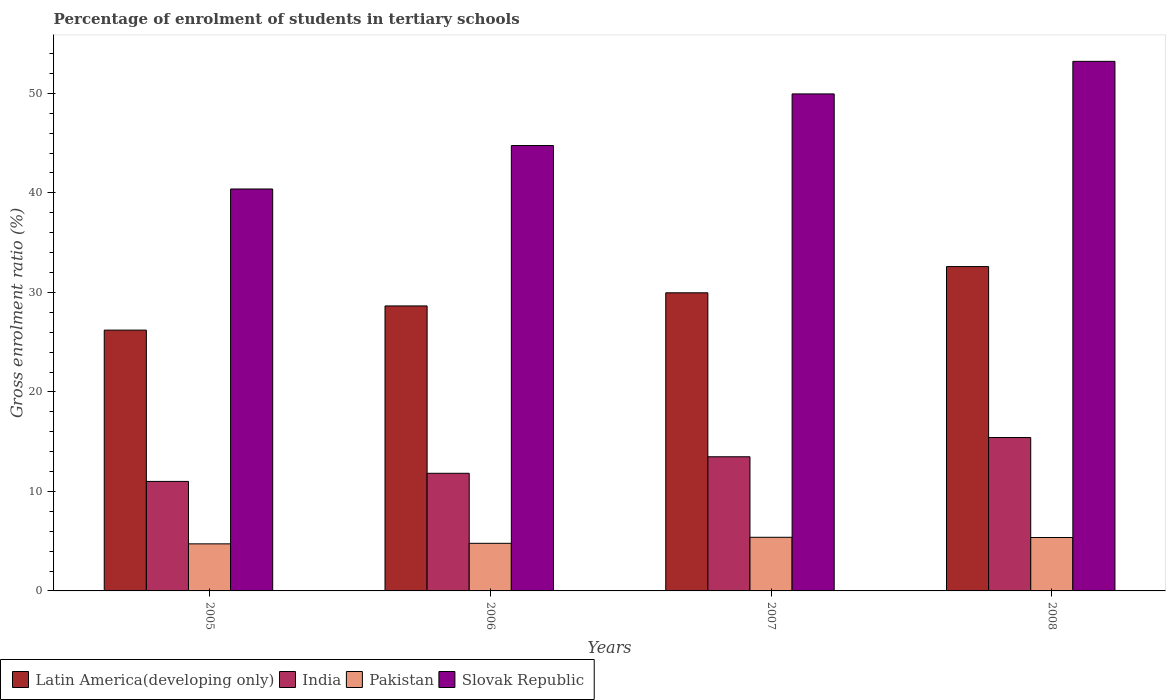How many different coloured bars are there?
Provide a short and direct response. 4. How many bars are there on the 1st tick from the left?
Offer a very short reply. 4. What is the label of the 2nd group of bars from the left?
Provide a short and direct response. 2006. What is the percentage of students enrolled in tertiary schools in Slovak Republic in 2006?
Make the answer very short. 44.76. Across all years, what is the maximum percentage of students enrolled in tertiary schools in Slovak Republic?
Ensure brevity in your answer.  53.22. Across all years, what is the minimum percentage of students enrolled in tertiary schools in Slovak Republic?
Provide a short and direct response. 40.39. In which year was the percentage of students enrolled in tertiary schools in India maximum?
Give a very brief answer. 2008. What is the total percentage of students enrolled in tertiary schools in Latin America(developing only) in the graph?
Offer a very short reply. 117.4. What is the difference between the percentage of students enrolled in tertiary schools in Latin America(developing only) in 2006 and that in 2008?
Ensure brevity in your answer.  -3.95. What is the difference between the percentage of students enrolled in tertiary schools in India in 2005 and the percentage of students enrolled in tertiary schools in Slovak Republic in 2006?
Offer a terse response. -33.75. What is the average percentage of students enrolled in tertiary schools in Slovak Republic per year?
Your response must be concise. 47.08. In the year 2007, what is the difference between the percentage of students enrolled in tertiary schools in India and percentage of students enrolled in tertiary schools in Slovak Republic?
Ensure brevity in your answer.  -36.46. What is the ratio of the percentage of students enrolled in tertiary schools in Latin America(developing only) in 2005 to that in 2008?
Your answer should be compact. 0.8. Is the percentage of students enrolled in tertiary schools in Latin America(developing only) in 2005 less than that in 2006?
Your answer should be very brief. Yes. Is the difference between the percentage of students enrolled in tertiary schools in India in 2006 and 2007 greater than the difference between the percentage of students enrolled in tertiary schools in Slovak Republic in 2006 and 2007?
Offer a terse response. Yes. What is the difference between the highest and the second highest percentage of students enrolled in tertiary schools in India?
Offer a terse response. 1.93. What is the difference between the highest and the lowest percentage of students enrolled in tertiary schools in India?
Keep it short and to the point. 4.41. In how many years, is the percentage of students enrolled in tertiary schools in Slovak Republic greater than the average percentage of students enrolled in tertiary schools in Slovak Republic taken over all years?
Your response must be concise. 2. Is it the case that in every year, the sum of the percentage of students enrolled in tertiary schools in Pakistan and percentage of students enrolled in tertiary schools in Slovak Republic is greater than the sum of percentage of students enrolled in tertiary schools in India and percentage of students enrolled in tertiary schools in Latin America(developing only)?
Offer a very short reply. No. What does the 4th bar from the right in 2008 represents?
Your answer should be very brief. Latin America(developing only). Are all the bars in the graph horizontal?
Provide a short and direct response. No. How many years are there in the graph?
Give a very brief answer. 4. What is the difference between two consecutive major ticks on the Y-axis?
Your answer should be very brief. 10. Are the values on the major ticks of Y-axis written in scientific E-notation?
Offer a terse response. No. Does the graph contain grids?
Make the answer very short. No. How many legend labels are there?
Your response must be concise. 4. How are the legend labels stacked?
Offer a very short reply. Horizontal. What is the title of the graph?
Provide a short and direct response. Percentage of enrolment of students in tertiary schools. What is the label or title of the Y-axis?
Provide a succinct answer. Gross enrolment ratio (%). What is the Gross enrolment ratio (%) in Latin America(developing only) in 2005?
Make the answer very short. 26.21. What is the Gross enrolment ratio (%) of India in 2005?
Provide a short and direct response. 11. What is the Gross enrolment ratio (%) of Pakistan in 2005?
Give a very brief answer. 4.73. What is the Gross enrolment ratio (%) of Slovak Republic in 2005?
Provide a short and direct response. 40.39. What is the Gross enrolment ratio (%) in Latin America(developing only) in 2006?
Keep it short and to the point. 28.64. What is the Gross enrolment ratio (%) in India in 2006?
Provide a succinct answer. 11.82. What is the Gross enrolment ratio (%) in Pakistan in 2006?
Provide a short and direct response. 4.78. What is the Gross enrolment ratio (%) of Slovak Republic in 2006?
Offer a terse response. 44.76. What is the Gross enrolment ratio (%) of Latin America(developing only) in 2007?
Your answer should be very brief. 29.96. What is the Gross enrolment ratio (%) of India in 2007?
Keep it short and to the point. 13.48. What is the Gross enrolment ratio (%) in Pakistan in 2007?
Give a very brief answer. 5.39. What is the Gross enrolment ratio (%) of Slovak Republic in 2007?
Keep it short and to the point. 49.95. What is the Gross enrolment ratio (%) of Latin America(developing only) in 2008?
Keep it short and to the point. 32.59. What is the Gross enrolment ratio (%) of India in 2008?
Make the answer very short. 15.42. What is the Gross enrolment ratio (%) of Pakistan in 2008?
Offer a terse response. 5.37. What is the Gross enrolment ratio (%) in Slovak Republic in 2008?
Provide a short and direct response. 53.22. Across all years, what is the maximum Gross enrolment ratio (%) of Latin America(developing only)?
Provide a succinct answer. 32.59. Across all years, what is the maximum Gross enrolment ratio (%) of India?
Your response must be concise. 15.42. Across all years, what is the maximum Gross enrolment ratio (%) in Pakistan?
Provide a succinct answer. 5.39. Across all years, what is the maximum Gross enrolment ratio (%) of Slovak Republic?
Offer a very short reply. 53.22. Across all years, what is the minimum Gross enrolment ratio (%) in Latin America(developing only)?
Provide a succinct answer. 26.21. Across all years, what is the minimum Gross enrolment ratio (%) in India?
Your answer should be compact. 11. Across all years, what is the minimum Gross enrolment ratio (%) of Pakistan?
Make the answer very short. 4.73. Across all years, what is the minimum Gross enrolment ratio (%) of Slovak Republic?
Your response must be concise. 40.39. What is the total Gross enrolment ratio (%) in Latin America(developing only) in the graph?
Provide a short and direct response. 117.4. What is the total Gross enrolment ratio (%) of India in the graph?
Offer a very short reply. 51.72. What is the total Gross enrolment ratio (%) in Pakistan in the graph?
Your answer should be compact. 20.27. What is the total Gross enrolment ratio (%) of Slovak Republic in the graph?
Offer a terse response. 188.31. What is the difference between the Gross enrolment ratio (%) of Latin America(developing only) in 2005 and that in 2006?
Your answer should be compact. -2.43. What is the difference between the Gross enrolment ratio (%) in India in 2005 and that in 2006?
Your response must be concise. -0.82. What is the difference between the Gross enrolment ratio (%) in Pakistan in 2005 and that in 2006?
Keep it short and to the point. -0.05. What is the difference between the Gross enrolment ratio (%) of Slovak Republic in 2005 and that in 2006?
Make the answer very short. -4.37. What is the difference between the Gross enrolment ratio (%) in Latin America(developing only) in 2005 and that in 2007?
Provide a succinct answer. -3.75. What is the difference between the Gross enrolment ratio (%) of India in 2005 and that in 2007?
Your answer should be very brief. -2.48. What is the difference between the Gross enrolment ratio (%) in Pakistan in 2005 and that in 2007?
Your answer should be very brief. -0.66. What is the difference between the Gross enrolment ratio (%) in Slovak Republic in 2005 and that in 2007?
Provide a succinct answer. -9.55. What is the difference between the Gross enrolment ratio (%) in Latin America(developing only) in 2005 and that in 2008?
Your answer should be very brief. -6.38. What is the difference between the Gross enrolment ratio (%) in India in 2005 and that in 2008?
Provide a short and direct response. -4.41. What is the difference between the Gross enrolment ratio (%) of Pakistan in 2005 and that in 2008?
Ensure brevity in your answer.  -0.64. What is the difference between the Gross enrolment ratio (%) in Slovak Republic in 2005 and that in 2008?
Offer a terse response. -12.83. What is the difference between the Gross enrolment ratio (%) in Latin America(developing only) in 2006 and that in 2007?
Your answer should be very brief. -1.32. What is the difference between the Gross enrolment ratio (%) in India in 2006 and that in 2007?
Ensure brevity in your answer.  -1.66. What is the difference between the Gross enrolment ratio (%) of Pakistan in 2006 and that in 2007?
Give a very brief answer. -0.61. What is the difference between the Gross enrolment ratio (%) of Slovak Republic in 2006 and that in 2007?
Make the answer very short. -5.19. What is the difference between the Gross enrolment ratio (%) in Latin America(developing only) in 2006 and that in 2008?
Make the answer very short. -3.95. What is the difference between the Gross enrolment ratio (%) in India in 2006 and that in 2008?
Give a very brief answer. -3.59. What is the difference between the Gross enrolment ratio (%) of Pakistan in 2006 and that in 2008?
Your answer should be compact. -0.59. What is the difference between the Gross enrolment ratio (%) of Slovak Republic in 2006 and that in 2008?
Make the answer very short. -8.46. What is the difference between the Gross enrolment ratio (%) of Latin America(developing only) in 2007 and that in 2008?
Make the answer very short. -2.63. What is the difference between the Gross enrolment ratio (%) in India in 2007 and that in 2008?
Your answer should be compact. -1.93. What is the difference between the Gross enrolment ratio (%) in Pakistan in 2007 and that in 2008?
Ensure brevity in your answer.  0.02. What is the difference between the Gross enrolment ratio (%) of Slovak Republic in 2007 and that in 2008?
Keep it short and to the point. -3.27. What is the difference between the Gross enrolment ratio (%) of Latin America(developing only) in 2005 and the Gross enrolment ratio (%) of India in 2006?
Your response must be concise. 14.39. What is the difference between the Gross enrolment ratio (%) in Latin America(developing only) in 2005 and the Gross enrolment ratio (%) in Pakistan in 2006?
Make the answer very short. 21.43. What is the difference between the Gross enrolment ratio (%) of Latin America(developing only) in 2005 and the Gross enrolment ratio (%) of Slovak Republic in 2006?
Your answer should be very brief. -18.55. What is the difference between the Gross enrolment ratio (%) in India in 2005 and the Gross enrolment ratio (%) in Pakistan in 2006?
Make the answer very short. 6.22. What is the difference between the Gross enrolment ratio (%) in India in 2005 and the Gross enrolment ratio (%) in Slovak Republic in 2006?
Provide a succinct answer. -33.75. What is the difference between the Gross enrolment ratio (%) of Pakistan in 2005 and the Gross enrolment ratio (%) of Slovak Republic in 2006?
Ensure brevity in your answer.  -40.03. What is the difference between the Gross enrolment ratio (%) of Latin America(developing only) in 2005 and the Gross enrolment ratio (%) of India in 2007?
Your answer should be compact. 12.73. What is the difference between the Gross enrolment ratio (%) in Latin America(developing only) in 2005 and the Gross enrolment ratio (%) in Pakistan in 2007?
Your answer should be compact. 20.82. What is the difference between the Gross enrolment ratio (%) in Latin America(developing only) in 2005 and the Gross enrolment ratio (%) in Slovak Republic in 2007?
Your response must be concise. -23.74. What is the difference between the Gross enrolment ratio (%) in India in 2005 and the Gross enrolment ratio (%) in Pakistan in 2007?
Your response must be concise. 5.61. What is the difference between the Gross enrolment ratio (%) in India in 2005 and the Gross enrolment ratio (%) in Slovak Republic in 2007?
Offer a very short reply. -38.94. What is the difference between the Gross enrolment ratio (%) of Pakistan in 2005 and the Gross enrolment ratio (%) of Slovak Republic in 2007?
Keep it short and to the point. -45.22. What is the difference between the Gross enrolment ratio (%) of Latin America(developing only) in 2005 and the Gross enrolment ratio (%) of India in 2008?
Your answer should be compact. 10.79. What is the difference between the Gross enrolment ratio (%) of Latin America(developing only) in 2005 and the Gross enrolment ratio (%) of Pakistan in 2008?
Offer a terse response. 20.84. What is the difference between the Gross enrolment ratio (%) in Latin America(developing only) in 2005 and the Gross enrolment ratio (%) in Slovak Republic in 2008?
Your response must be concise. -27.01. What is the difference between the Gross enrolment ratio (%) of India in 2005 and the Gross enrolment ratio (%) of Pakistan in 2008?
Offer a very short reply. 5.64. What is the difference between the Gross enrolment ratio (%) of India in 2005 and the Gross enrolment ratio (%) of Slovak Republic in 2008?
Give a very brief answer. -42.21. What is the difference between the Gross enrolment ratio (%) in Pakistan in 2005 and the Gross enrolment ratio (%) in Slovak Republic in 2008?
Offer a terse response. -48.49. What is the difference between the Gross enrolment ratio (%) of Latin America(developing only) in 2006 and the Gross enrolment ratio (%) of India in 2007?
Offer a very short reply. 15.16. What is the difference between the Gross enrolment ratio (%) of Latin America(developing only) in 2006 and the Gross enrolment ratio (%) of Pakistan in 2007?
Provide a succinct answer. 23.25. What is the difference between the Gross enrolment ratio (%) in Latin America(developing only) in 2006 and the Gross enrolment ratio (%) in Slovak Republic in 2007?
Provide a succinct answer. -21.31. What is the difference between the Gross enrolment ratio (%) of India in 2006 and the Gross enrolment ratio (%) of Pakistan in 2007?
Provide a short and direct response. 6.43. What is the difference between the Gross enrolment ratio (%) in India in 2006 and the Gross enrolment ratio (%) in Slovak Republic in 2007?
Provide a succinct answer. -38.12. What is the difference between the Gross enrolment ratio (%) of Pakistan in 2006 and the Gross enrolment ratio (%) of Slovak Republic in 2007?
Ensure brevity in your answer.  -45.16. What is the difference between the Gross enrolment ratio (%) of Latin America(developing only) in 2006 and the Gross enrolment ratio (%) of India in 2008?
Give a very brief answer. 13.22. What is the difference between the Gross enrolment ratio (%) of Latin America(developing only) in 2006 and the Gross enrolment ratio (%) of Pakistan in 2008?
Give a very brief answer. 23.27. What is the difference between the Gross enrolment ratio (%) in Latin America(developing only) in 2006 and the Gross enrolment ratio (%) in Slovak Republic in 2008?
Keep it short and to the point. -24.58. What is the difference between the Gross enrolment ratio (%) in India in 2006 and the Gross enrolment ratio (%) in Pakistan in 2008?
Make the answer very short. 6.45. What is the difference between the Gross enrolment ratio (%) of India in 2006 and the Gross enrolment ratio (%) of Slovak Republic in 2008?
Keep it short and to the point. -41.4. What is the difference between the Gross enrolment ratio (%) of Pakistan in 2006 and the Gross enrolment ratio (%) of Slovak Republic in 2008?
Your answer should be very brief. -48.44. What is the difference between the Gross enrolment ratio (%) in Latin America(developing only) in 2007 and the Gross enrolment ratio (%) in India in 2008?
Provide a short and direct response. 14.54. What is the difference between the Gross enrolment ratio (%) in Latin America(developing only) in 2007 and the Gross enrolment ratio (%) in Pakistan in 2008?
Give a very brief answer. 24.59. What is the difference between the Gross enrolment ratio (%) of Latin America(developing only) in 2007 and the Gross enrolment ratio (%) of Slovak Republic in 2008?
Keep it short and to the point. -23.26. What is the difference between the Gross enrolment ratio (%) of India in 2007 and the Gross enrolment ratio (%) of Pakistan in 2008?
Your answer should be compact. 8.11. What is the difference between the Gross enrolment ratio (%) in India in 2007 and the Gross enrolment ratio (%) in Slovak Republic in 2008?
Make the answer very short. -39.74. What is the difference between the Gross enrolment ratio (%) in Pakistan in 2007 and the Gross enrolment ratio (%) in Slovak Republic in 2008?
Offer a terse response. -47.83. What is the average Gross enrolment ratio (%) of Latin America(developing only) per year?
Make the answer very short. 29.35. What is the average Gross enrolment ratio (%) in India per year?
Provide a short and direct response. 12.93. What is the average Gross enrolment ratio (%) of Pakistan per year?
Give a very brief answer. 5.07. What is the average Gross enrolment ratio (%) in Slovak Republic per year?
Make the answer very short. 47.08. In the year 2005, what is the difference between the Gross enrolment ratio (%) in Latin America(developing only) and Gross enrolment ratio (%) in India?
Offer a very short reply. 15.21. In the year 2005, what is the difference between the Gross enrolment ratio (%) of Latin America(developing only) and Gross enrolment ratio (%) of Pakistan?
Your response must be concise. 21.48. In the year 2005, what is the difference between the Gross enrolment ratio (%) of Latin America(developing only) and Gross enrolment ratio (%) of Slovak Republic?
Make the answer very short. -14.18. In the year 2005, what is the difference between the Gross enrolment ratio (%) in India and Gross enrolment ratio (%) in Pakistan?
Provide a short and direct response. 6.27. In the year 2005, what is the difference between the Gross enrolment ratio (%) in India and Gross enrolment ratio (%) in Slovak Republic?
Your answer should be compact. -29.39. In the year 2005, what is the difference between the Gross enrolment ratio (%) in Pakistan and Gross enrolment ratio (%) in Slovak Republic?
Offer a very short reply. -35.66. In the year 2006, what is the difference between the Gross enrolment ratio (%) in Latin America(developing only) and Gross enrolment ratio (%) in India?
Make the answer very short. 16.82. In the year 2006, what is the difference between the Gross enrolment ratio (%) in Latin America(developing only) and Gross enrolment ratio (%) in Pakistan?
Give a very brief answer. 23.86. In the year 2006, what is the difference between the Gross enrolment ratio (%) of Latin America(developing only) and Gross enrolment ratio (%) of Slovak Republic?
Give a very brief answer. -16.12. In the year 2006, what is the difference between the Gross enrolment ratio (%) of India and Gross enrolment ratio (%) of Pakistan?
Give a very brief answer. 7.04. In the year 2006, what is the difference between the Gross enrolment ratio (%) of India and Gross enrolment ratio (%) of Slovak Republic?
Your answer should be compact. -32.94. In the year 2006, what is the difference between the Gross enrolment ratio (%) in Pakistan and Gross enrolment ratio (%) in Slovak Republic?
Offer a terse response. -39.98. In the year 2007, what is the difference between the Gross enrolment ratio (%) in Latin America(developing only) and Gross enrolment ratio (%) in India?
Your response must be concise. 16.48. In the year 2007, what is the difference between the Gross enrolment ratio (%) in Latin America(developing only) and Gross enrolment ratio (%) in Pakistan?
Offer a very short reply. 24.57. In the year 2007, what is the difference between the Gross enrolment ratio (%) in Latin America(developing only) and Gross enrolment ratio (%) in Slovak Republic?
Your response must be concise. -19.99. In the year 2007, what is the difference between the Gross enrolment ratio (%) in India and Gross enrolment ratio (%) in Pakistan?
Your answer should be very brief. 8.09. In the year 2007, what is the difference between the Gross enrolment ratio (%) in India and Gross enrolment ratio (%) in Slovak Republic?
Your answer should be compact. -36.47. In the year 2007, what is the difference between the Gross enrolment ratio (%) of Pakistan and Gross enrolment ratio (%) of Slovak Republic?
Offer a terse response. -44.56. In the year 2008, what is the difference between the Gross enrolment ratio (%) of Latin America(developing only) and Gross enrolment ratio (%) of India?
Make the answer very short. 17.18. In the year 2008, what is the difference between the Gross enrolment ratio (%) in Latin America(developing only) and Gross enrolment ratio (%) in Pakistan?
Provide a succinct answer. 27.23. In the year 2008, what is the difference between the Gross enrolment ratio (%) in Latin America(developing only) and Gross enrolment ratio (%) in Slovak Republic?
Your answer should be compact. -20.62. In the year 2008, what is the difference between the Gross enrolment ratio (%) of India and Gross enrolment ratio (%) of Pakistan?
Your response must be concise. 10.05. In the year 2008, what is the difference between the Gross enrolment ratio (%) in India and Gross enrolment ratio (%) in Slovak Republic?
Your answer should be compact. -37.8. In the year 2008, what is the difference between the Gross enrolment ratio (%) of Pakistan and Gross enrolment ratio (%) of Slovak Republic?
Ensure brevity in your answer.  -47.85. What is the ratio of the Gross enrolment ratio (%) in Latin America(developing only) in 2005 to that in 2006?
Your answer should be very brief. 0.92. What is the ratio of the Gross enrolment ratio (%) of India in 2005 to that in 2006?
Ensure brevity in your answer.  0.93. What is the ratio of the Gross enrolment ratio (%) of Pakistan in 2005 to that in 2006?
Your answer should be very brief. 0.99. What is the ratio of the Gross enrolment ratio (%) of Slovak Republic in 2005 to that in 2006?
Keep it short and to the point. 0.9. What is the ratio of the Gross enrolment ratio (%) of Latin America(developing only) in 2005 to that in 2007?
Offer a very short reply. 0.87. What is the ratio of the Gross enrolment ratio (%) in India in 2005 to that in 2007?
Your answer should be very brief. 0.82. What is the ratio of the Gross enrolment ratio (%) in Pakistan in 2005 to that in 2007?
Offer a very short reply. 0.88. What is the ratio of the Gross enrolment ratio (%) of Slovak Republic in 2005 to that in 2007?
Provide a succinct answer. 0.81. What is the ratio of the Gross enrolment ratio (%) in Latin America(developing only) in 2005 to that in 2008?
Offer a terse response. 0.8. What is the ratio of the Gross enrolment ratio (%) in India in 2005 to that in 2008?
Your answer should be compact. 0.71. What is the ratio of the Gross enrolment ratio (%) in Pakistan in 2005 to that in 2008?
Offer a terse response. 0.88. What is the ratio of the Gross enrolment ratio (%) of Slovak Republic in 2005 to that in 2008?
Keep it short and to the point. 0.76. What is the ratio of the Gross enrolment ratio (%) of Latin America(developing only) in 2006 to that in 2007?
Keep it short and to the point. 0.96. What is the ratio of the Gross enrolment ratio (%) of India in 2006 to that in 2007?
Make the answer very short. 0.88. What is the ratio of the Gross enrolment ratio (%) of Pakistan in 2006 to that in 2007?
Offer a very short reply. 0.89. What is the ratio of the Gross enrolment ratio (%) of Slovak Republic in 2006 to that in 2007?
Offer a terse response. 0.9. What is the ratio of the Gross enrolment ratio (%) of Latin America(developing only) in 2006 to that in 2008?
Your answer should be very brief. 0.88. What is the ratio of the Gross enrolment ratio (%) in India in 2006 to that in 2008?
Provide a succinct answer. 0.77. What is the ratio of the Gross enrolment ratio (%) of Pakistan in 2006 to that in 2008?
Your response must be concise. 0.89. What is the ratio of the Gross enrolment ratio (%) in Slovak Republic in 2006 to that in 2008?
Your answer should be very brief. 0.84. What is the ratio of the Gross enrolment ratio (%) in Latin America(developing only) in 2007 to that in 2008?
Your response must be concise. 0.92. What is the ratio of the Gross enrolment ratio (%) in India in 2007 to that in 2008?
Offer a very short reply. 0.87. What is the ratio of the Gross enrolment ratio (%) of Slovak Republic in 2007 to that in 2008?
Keep it short and to the point. 0.94. What is the difference between the highest and the second highest Gross enrolment ratio (%) of Latin America(developing only)?
Offer a terse response. 2.63. What is the difference between the highest and the second highest Gross enrolment ratio (%) in India?
Give a very brief answer. 1.93. What is the difference between the highest and the second highest Gross enrolment ratio (%) of Pakistan?
Your answer should be compact. 0.02. What is the difference between the highest and the second highest Gross enrolment ratio (%) of Slovak Republic?
Keep it short and to the point. 3.27. What is the difference between the highest and the lowest Gross enrolment ratio (%) of Latin America(developing only)?
Give a very brief answer. 6.38. What is the difference between the highest and the lowest Gross enrolment ratio (%) of India?
Offer a terse response. 4.41. What is the difference between the highest and the lowest Gross enrolment ratio (%) of Pakistan?
Offer a very short reply. 0.66. What is the difference between the highest and the lowest Gross enrolment ratio (%) of Slovak Republic?
Provide a short and direct response. 12.83. 